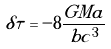Convert formula to latex. <formula><loc_0><loc_0><loc_500><loc_500>\delta \tau = - 8 \frac { G M a } { b c ^ { 3 } }</formula> 